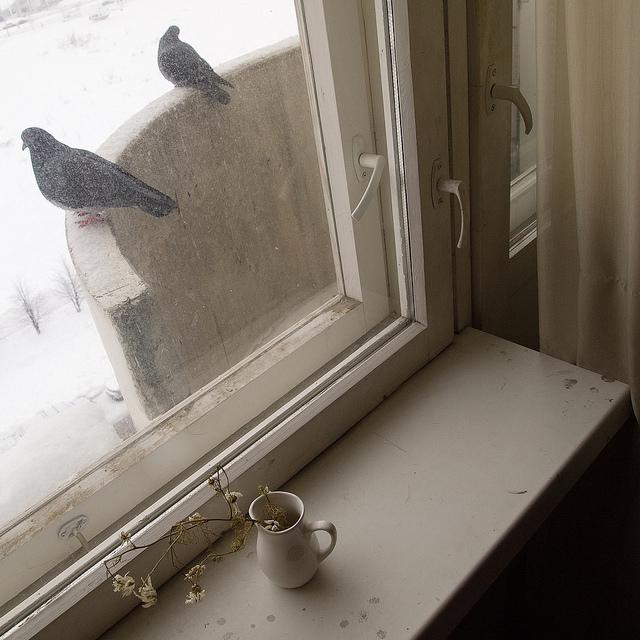What color is the bird?
Keep it brief. Black. How many birds are in the photo?
Write a very short answer. 2. Are there any curtains on the window?
Give a very brief answer. No. What color is the bird's chest?
Write a very short answer. Black. Are the flowers alive?
Answer briefly. No. What was left on the window sill for the bird?
Short answer required. Seed. What is the curved cement structure that the birds are in?
Be succinct. Wall. What is outside of the window?
Quick response, please. Birds. 